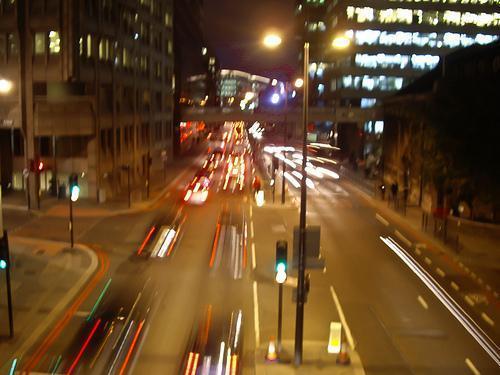How many traffic lights are in the picture?
Give a very brief answer. 2. How many green lights are visible in the photo?
Give a very brief answer. 2. 